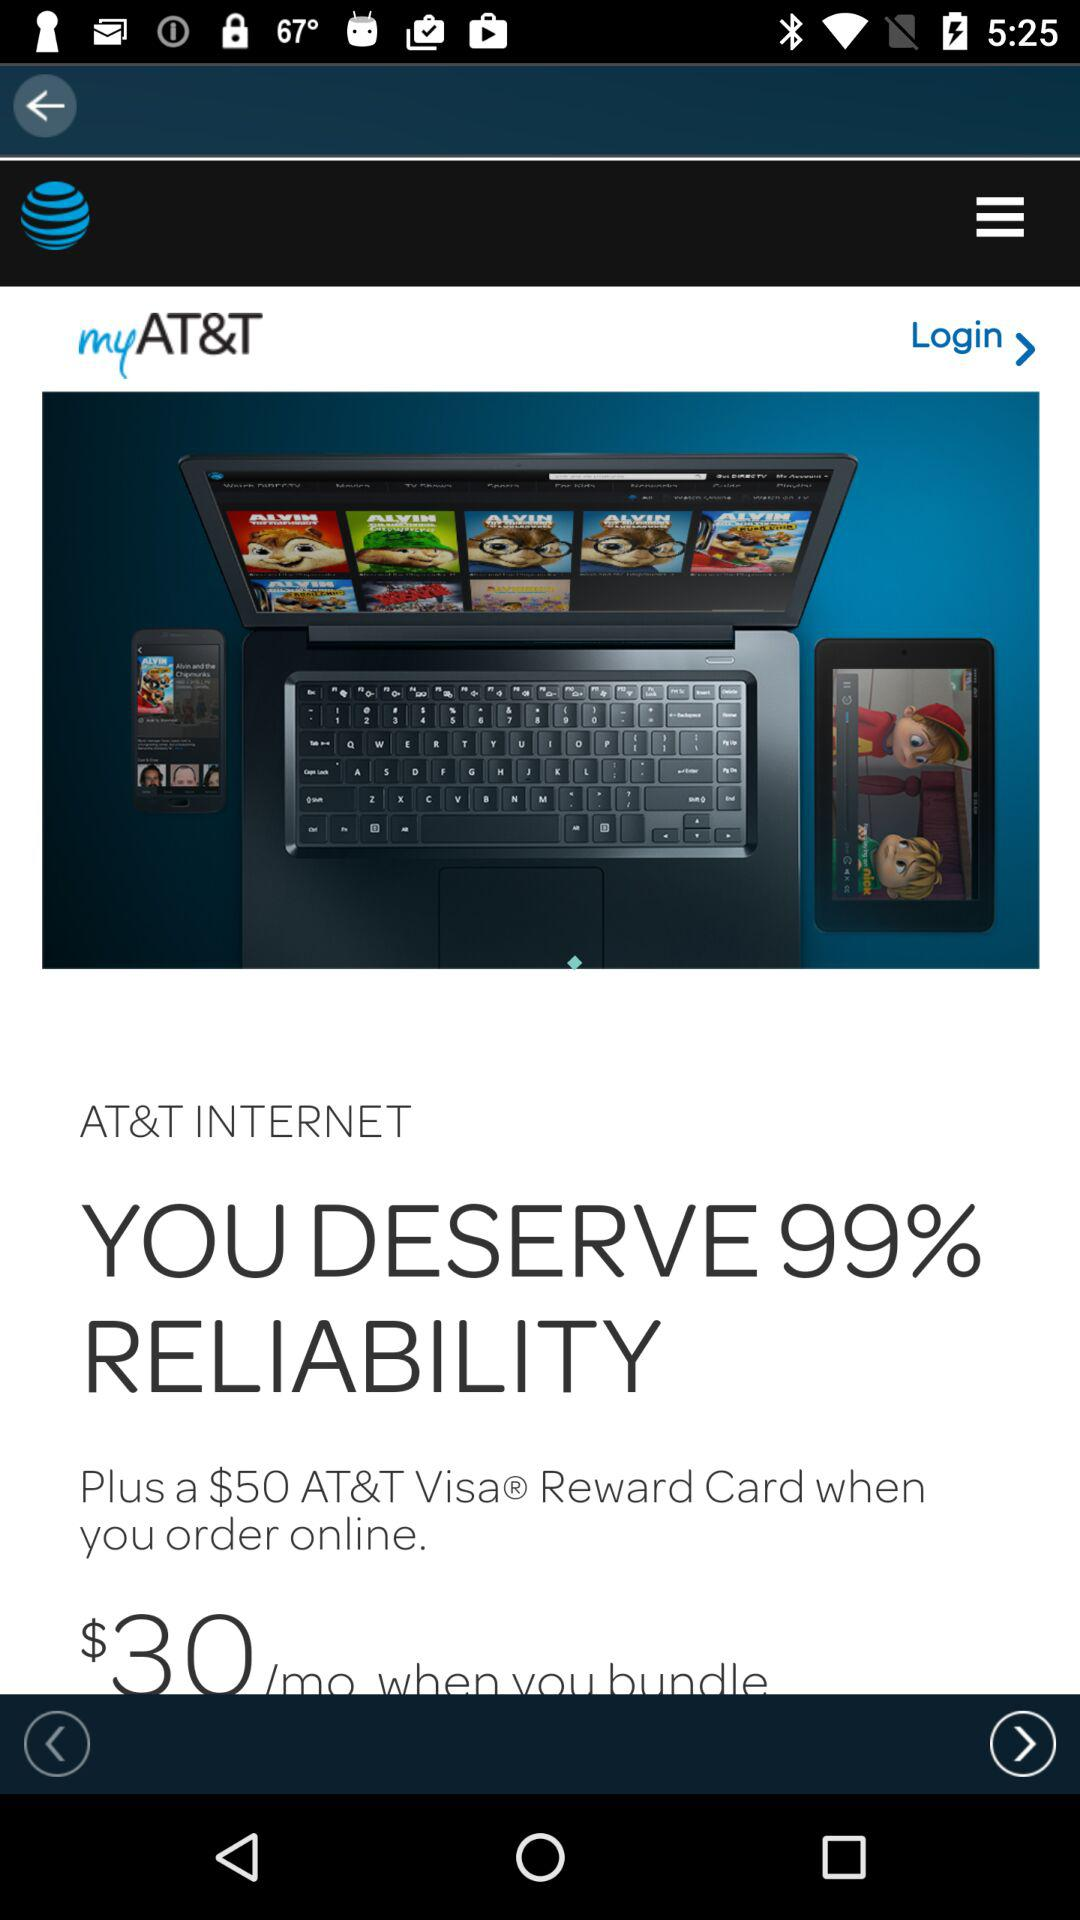What is the application name? The application name is "myAT&T". 